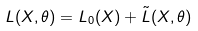<formula> <loc_0><loc_0><loc_500><loc_500>L ( X , \theta ) = L _ { 0 } ( X ) + \tilde { L } ( X , \theta )</formula> 